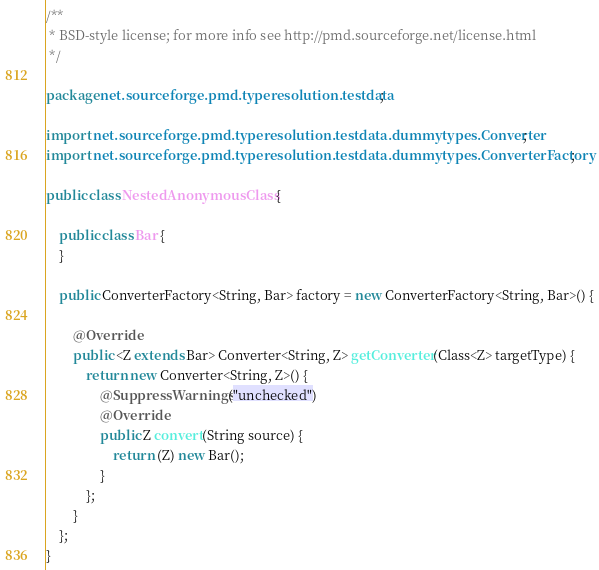Convert code to text. <code><loc_0><loc_0><loc_500><loc_500><_Java_>/**
 * BSD-style license; for more info see http://pmd.sourceforge.net/license.html
 */

package net.sourceforge.pmd.typeresolution.testdata;

import net.sourceforge.pmd.typeresolution.testdata.dummytypes.Converter;
import net.sourceforge.pmd.typeresolution.testdata.dummytypes.ConverterFactory;

public class NestedAnonymousClass {

    public class Bar {
    }
    
    public ConverterFactory<String, Bar> factory = new ConverterFactory<String, Bar>() {

        @Override
        public <Z extends Bar> Converter<String, Z> getConverter(Class<Z> targetType) {
            return new Converter<String, Z>() {
                @SuppressWarnings("unchecked")
                @Override
                public Z convert(String source) {
                    return (Z) new Bar();
                }
            };
        }
    };
}
</code> 